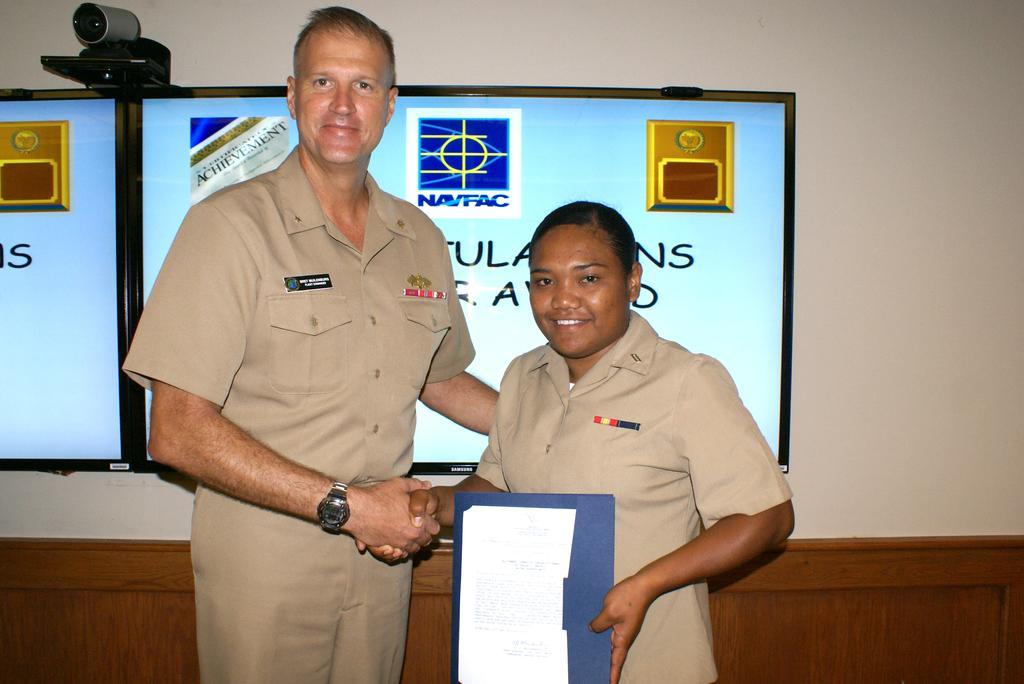Please provide a concise description of this image. In this picture we can see two persons,they are smiling and in the background we can see a wall,screens. 